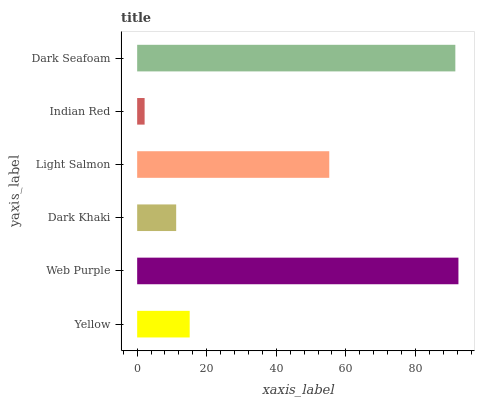Is Indian Red the minimum?
Answer yes or no. Yes. Is Web Purple the maximum?
Answer yes or no. Yes. Is Dark Khaki the minimum?
Answer yes or no. No. Is Dark Khaki the maximum?
Answer yes or no. No. Is Web Purple greater than Dark Khaki?
Answer yes or no. Yes. Is Dark Khaki less than Web Purple?
Answer yes or no. Yes. Is Dark Khaki greater than Web Purple?
Answer yes or no. No. Is Web Purple less than Dark Khaki?
Answer yes or no. No. Is Light Salmon the high median?
Answer yes or no. Yes. Is Yellow the low median?
Answer yes or no. Yes. Is Yellow the high median?
Answer yes or no. No. Is Dark Khaki the low median?
Answer yes or no. No. 